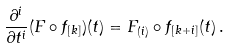Convert formula to latex. <formula><loc_0><loc_0><loc_500><loc_500>\frac { \partial ^ { i } } { \partial t ^ { i } } ( F \circ f _ { [ k ] } ) ( t ) = F _ { ( i ) } \circ f _ { [ k + i ] } ( t ) \, .</formula> 